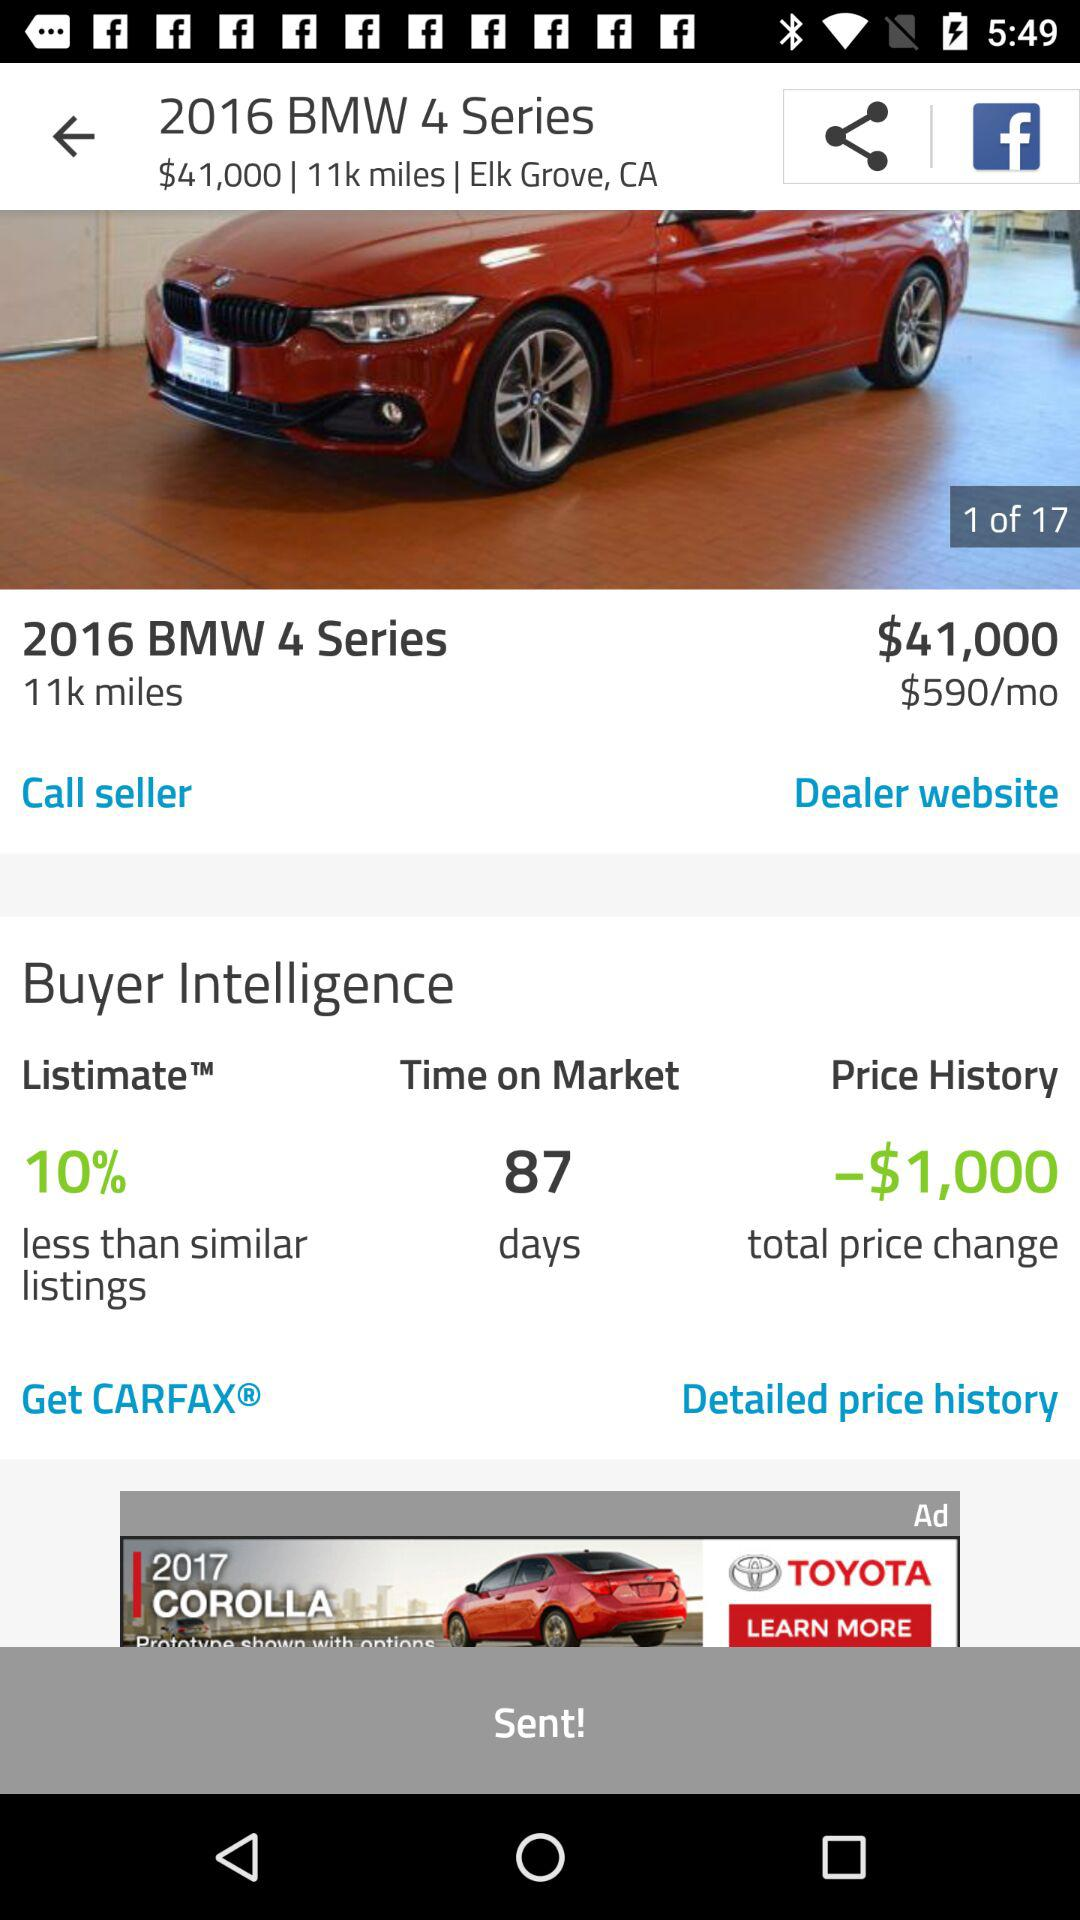What is the distance shown in the 2016 BMW 4 Series? The distance is 11k miles. 